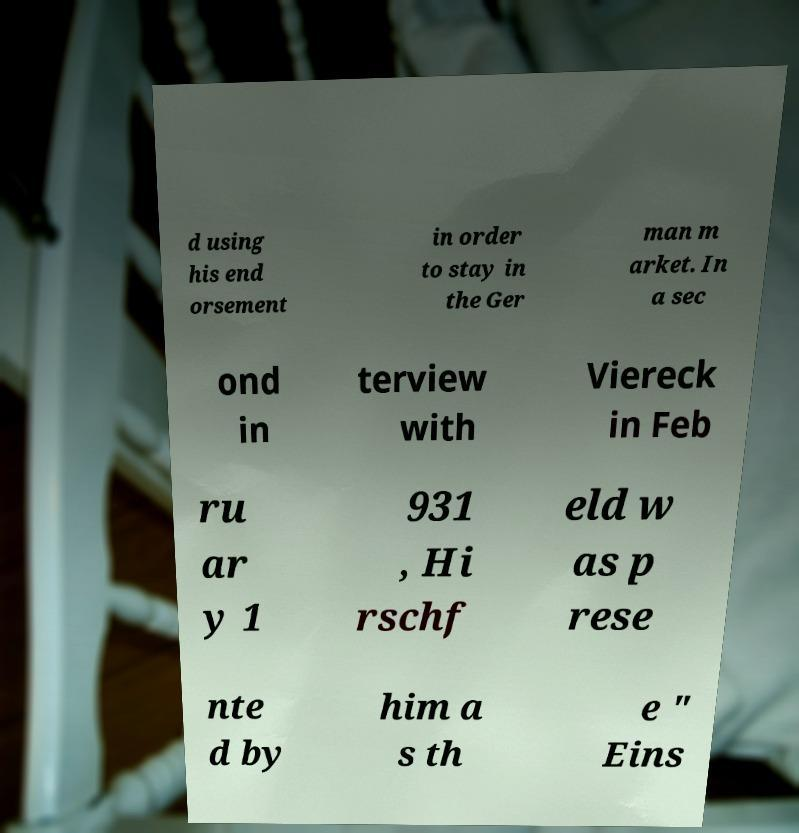I need the written content from this picture converted into text. Can you do that? d using his end orsement in order to stay in the Ger man m arket. In a sec ond in terview with Viereck in Feb ru ar y 1 931 , Hi rschf eld w as p rese nte d by him a s th e " Eins 